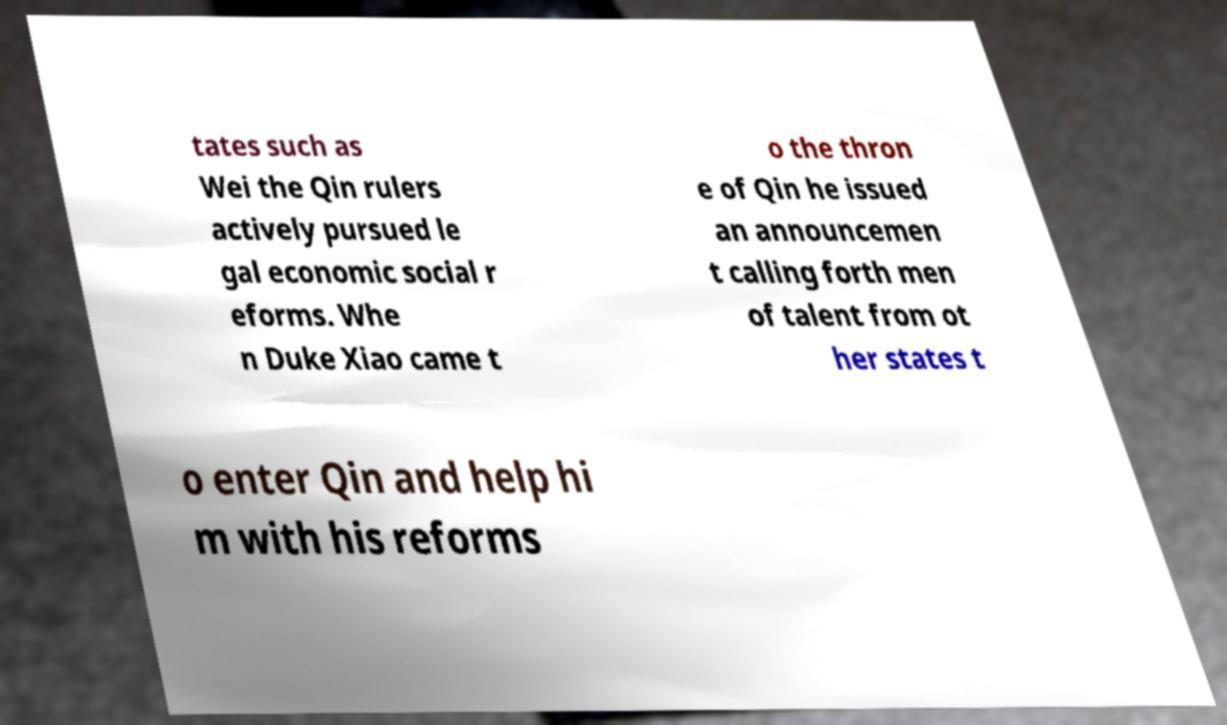What messages or text are displayed in this image? I need them in a readable, typed format. tates such as Wei the Qin rulers actively pursued le gal economic social r eforms. Whe n Duke Xiao came t o the thron e of Qin he issued an announcemen t calling forth men of talent from ot her states t o enter Qin and help hi m with his reforms 